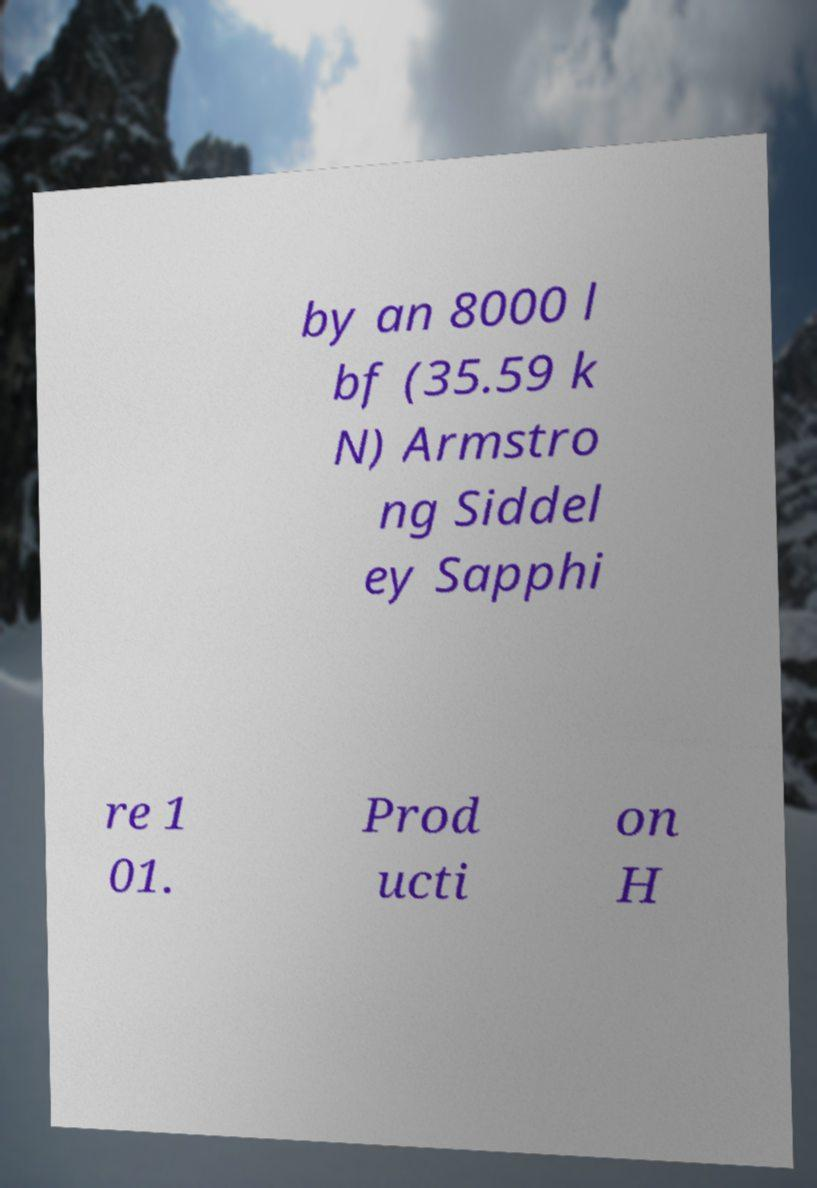Please read and relay the text visible in this image. What does it say? by an 8000 l bf (35.59 k N) Armstro ng Siddel ey Sapphi re 1 01. Prod ucti on H 